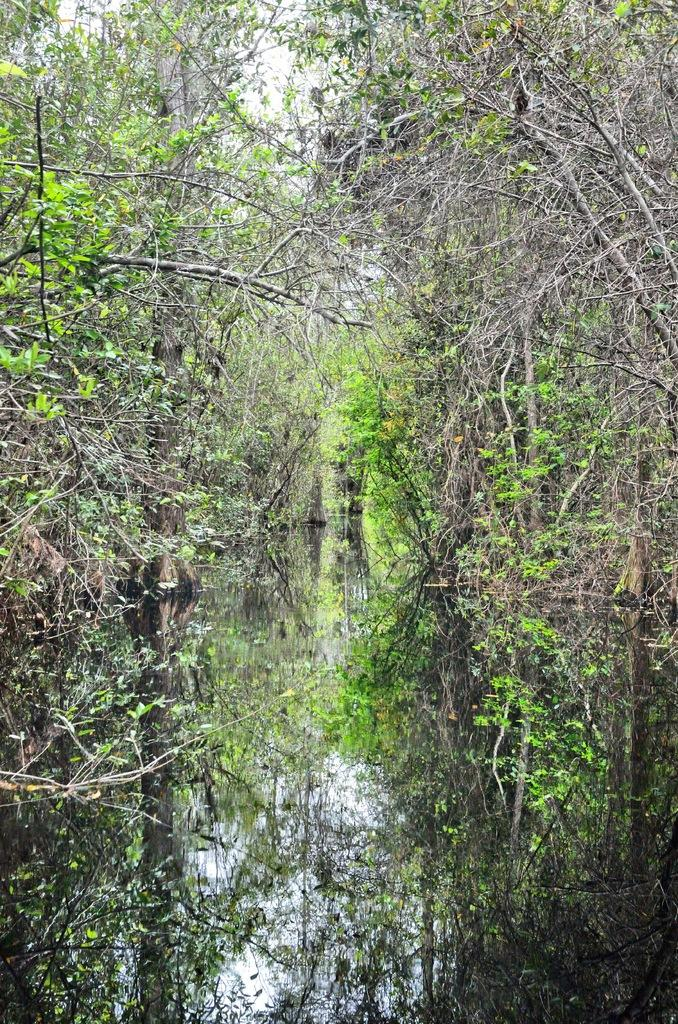What type of vegetation can be seen in the image? There are many trees and plants in the image. What is the reflection of in the water surface? The reflection of trees, plants, and the sky is visible on the water surface. What part of the natural environment is visible in the image? The sky is visible in the image. What type of wound can be seen on the tree in the image? There is no wound visible on any tree in the image. How many weeks has it been since the plants were last watered in the image? There is no information about the watering schedule of the plants in the image. 